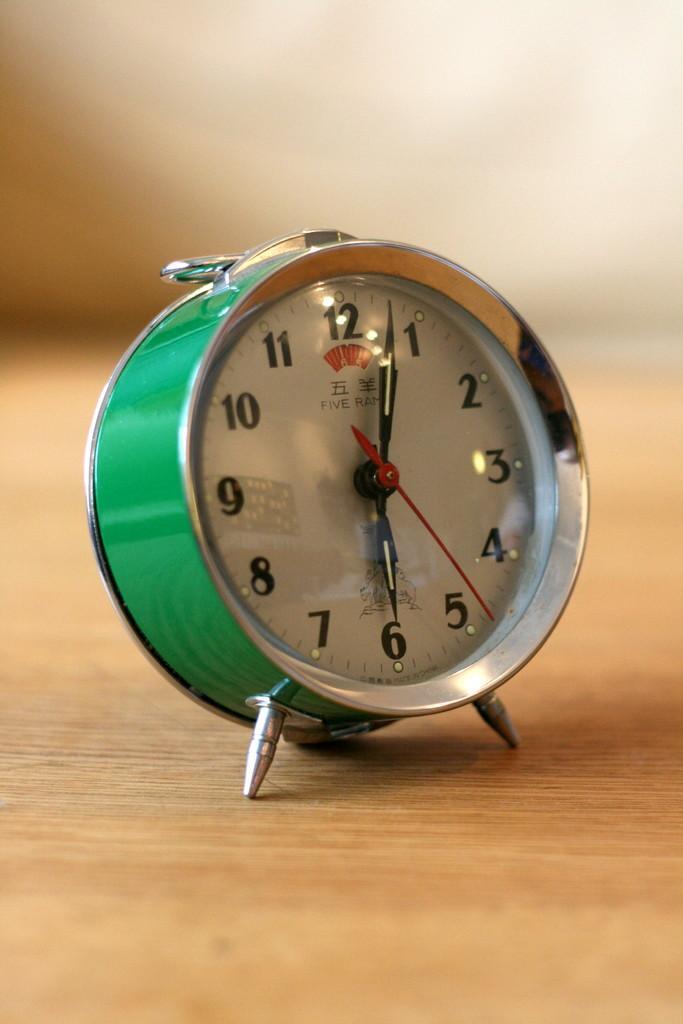Could you give a brief overview of what you see in this image? There is a green color clock on the wooden surface. In the background it is blurred. 